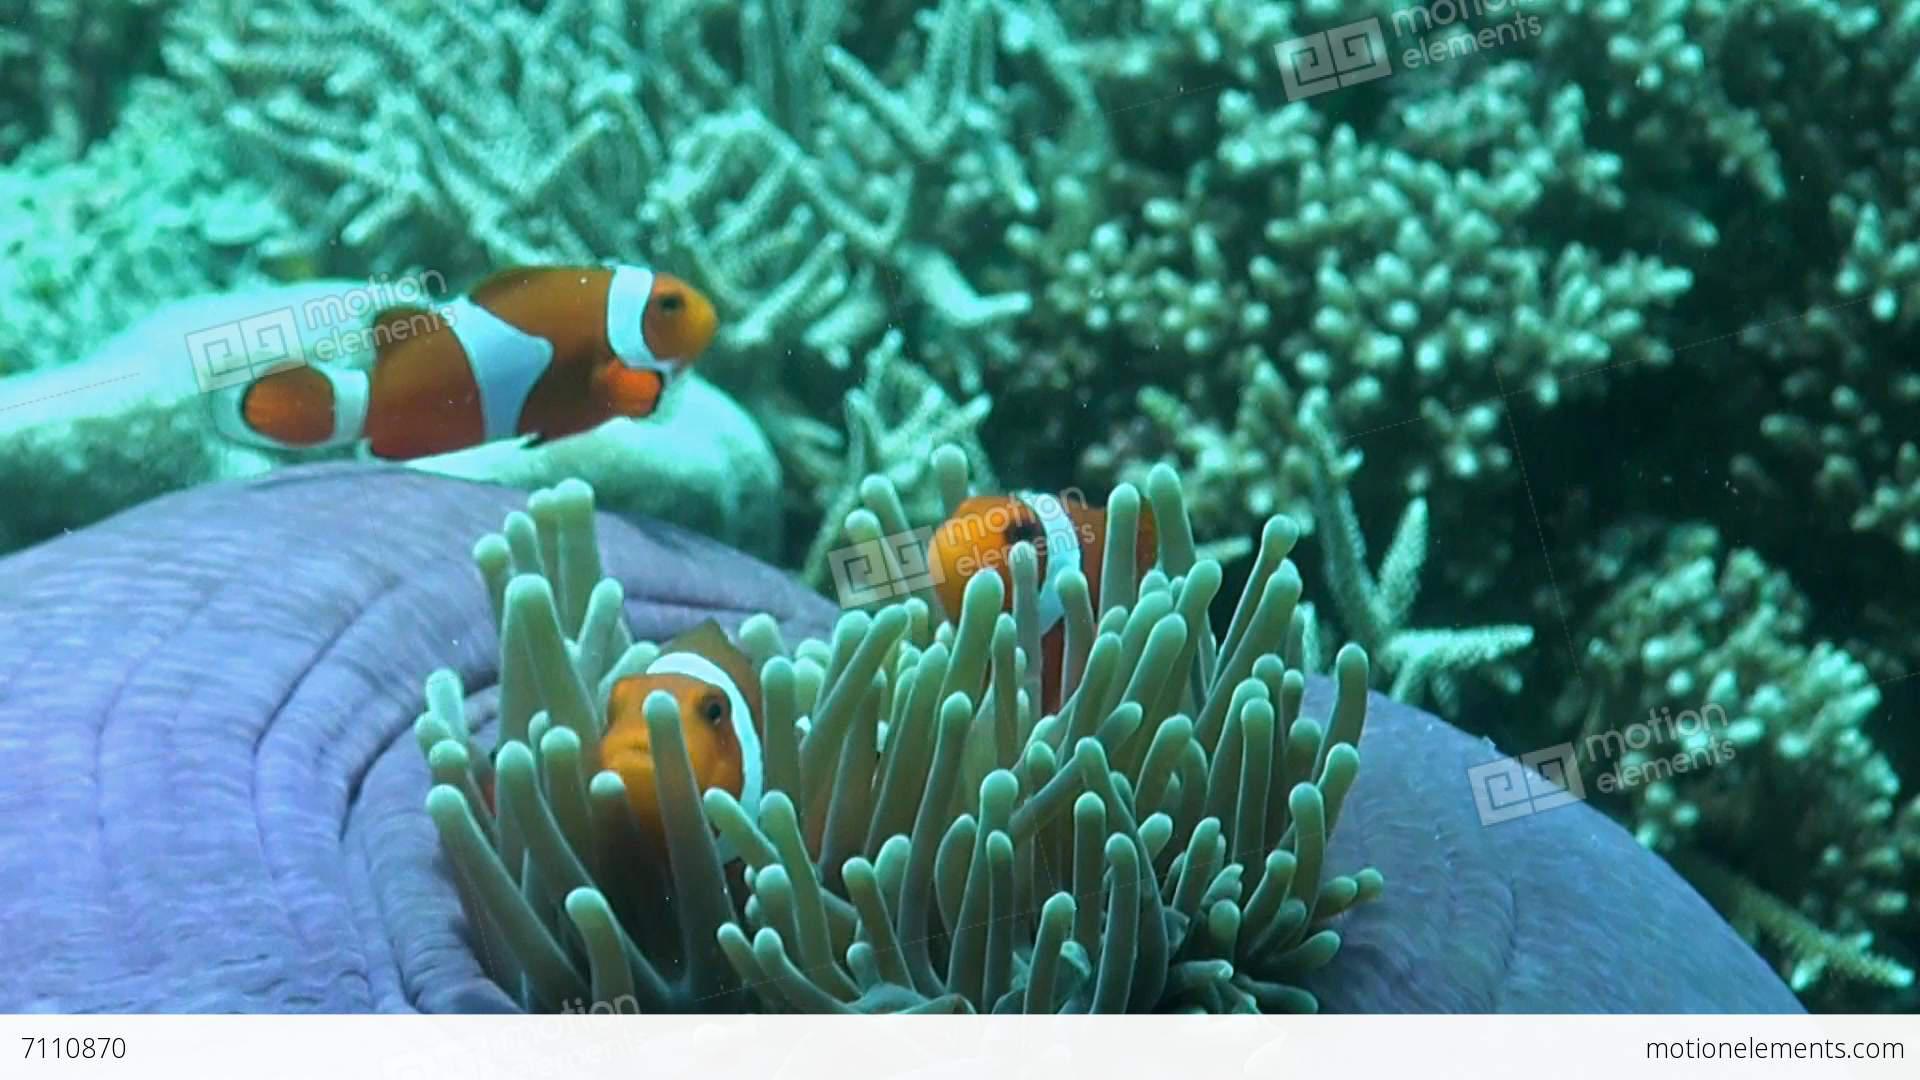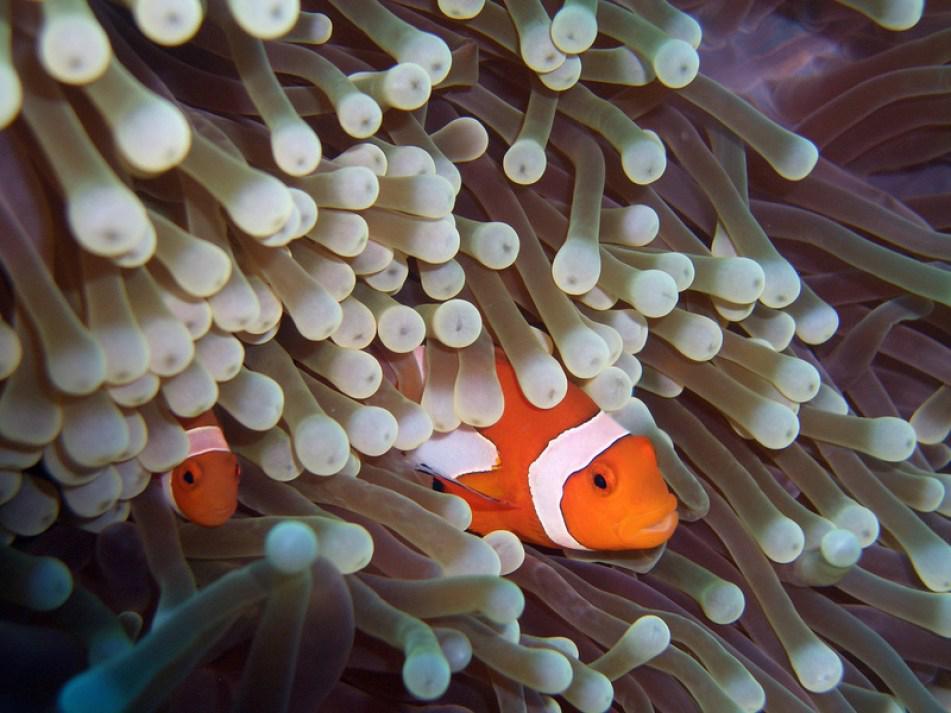The first image is the image on the left, the second image is the image on the right. Analyze the images presented: Is the assertion "The right image contains exactly one clown fish." valid? Answer yes or no. No. The first image is the image on the left, the second image is the image on the right. For the images displayed, is the sentence "An image shows exactly one clownfish swimming near neutral-colored anemone tendrils." factually correct? Answer yes or no. No. 